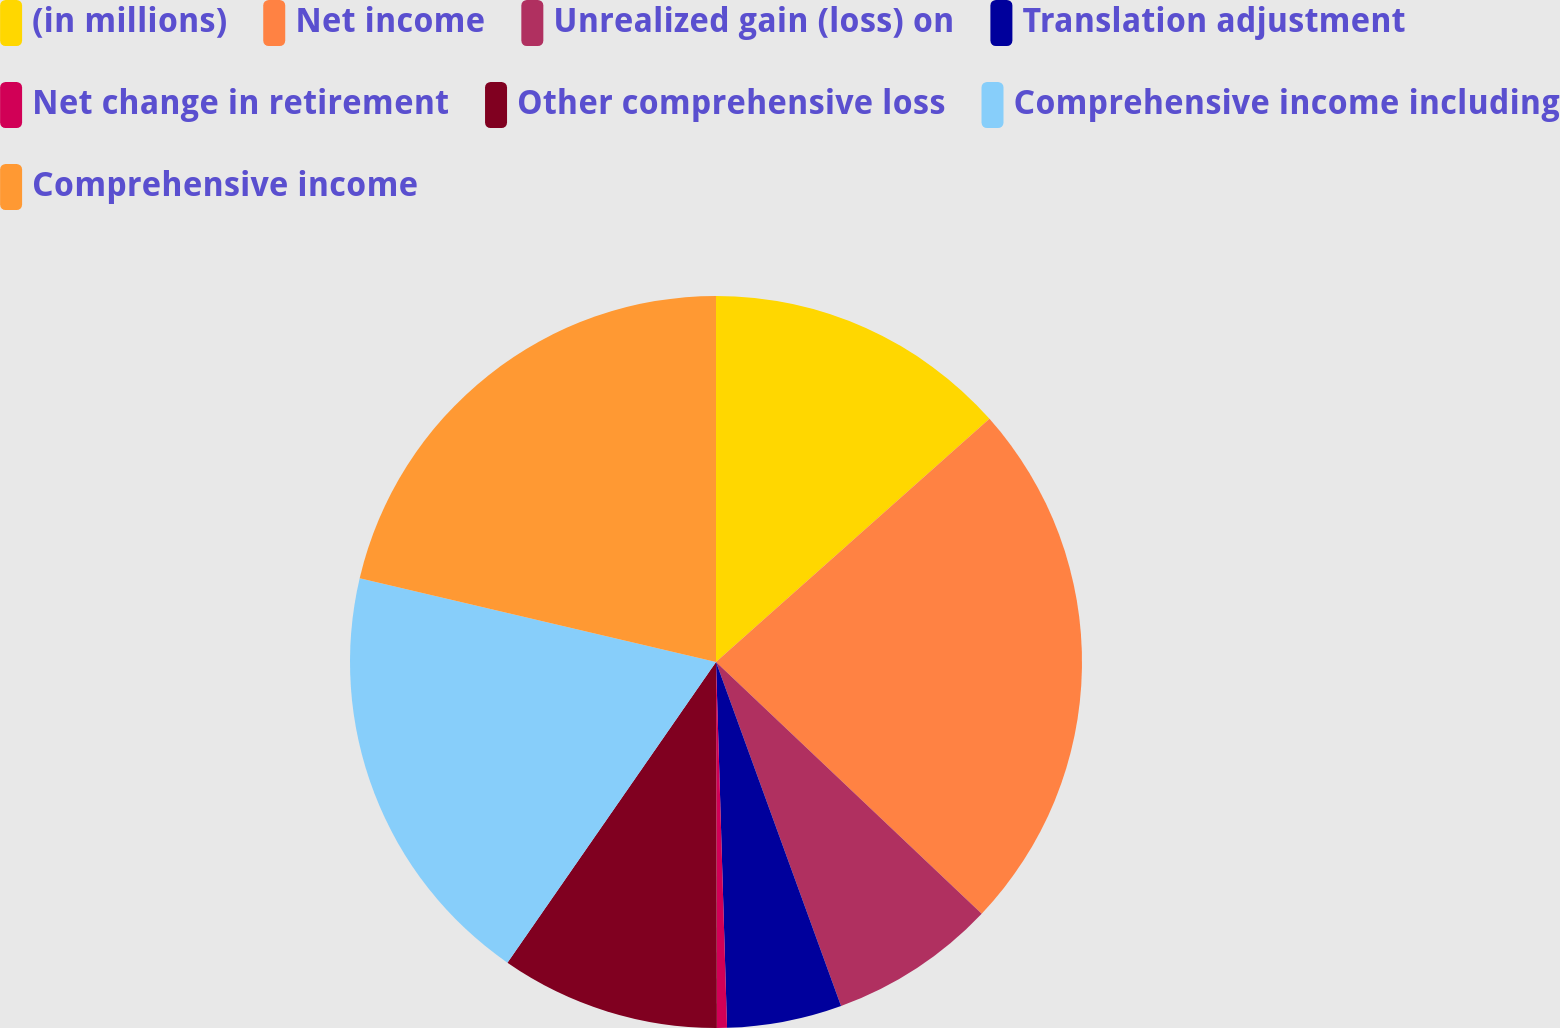<chart> <loc_0><loc_0><loc_500><loc_500><pie_chart><fcel>(in millions)<fcel>Net income<fcel>Unrealized gain (loss) on<fcel>Translation adjustment<fcel>Net change in retirement<fcel>Other comprehensive loss<fcel>Comprehensive income including<fcel>Comprehensive income<nl><fcel>13.43%<fcel>23.64%<fcel>7.38%<fcel>5.07%<fcel>0.44%<fcel>9.69%<fcel>19.02%<fcel>21.33%<nl></chart> 